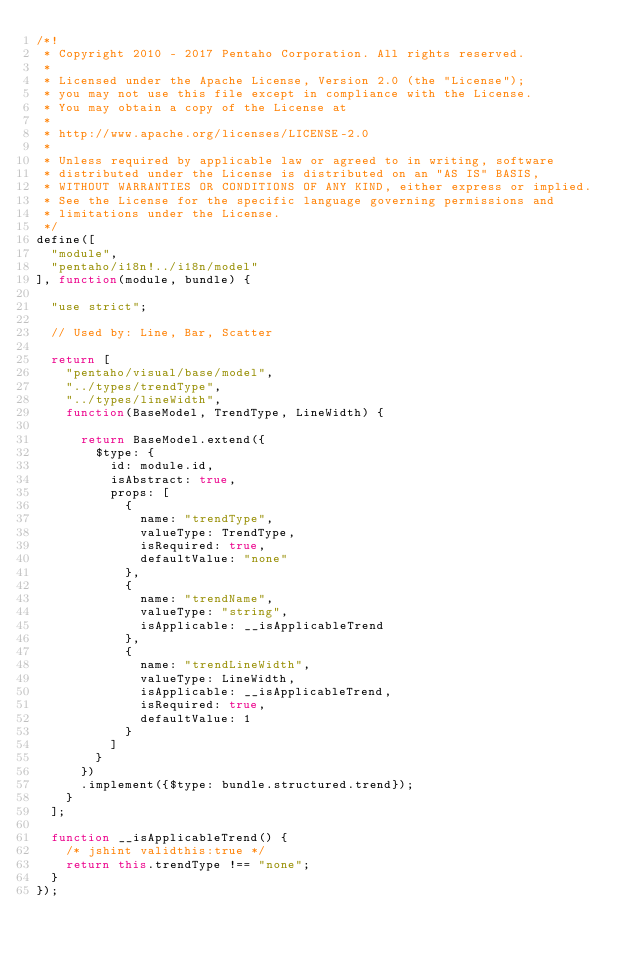Convert code to text. <code><loc_0><loc_0><loc_500><loc_500><_JavaScript_>/*!
 * Copyright 2010 - 2017 Pentaho Corporation. All rights reserved.
 *
 * Licensed under the Apache License, Version 2.0 (the "License");
 * you may not use this file except in compliance with the License.
 * You may obtain a copy of the License at
 *
 * http://www.apache.org/licenses/LICENSE-2.0
 *
 * Unless required by applicable law or agreed to in writing, software
 * distributed under the License is distributed on an "AS IS" BASIS,
 * WITHOUT WARRANTIES OR CONDITIONS OF ANY KIND, either express or implied.
 * See the License for the specific language governing permissions and
 * limitations under the License.
 */
define([
  "module",
  "pentaho/i18n!../i18n/model"
], function(module, bundle) {

  "use strict";

  // Used by: Line, Bar, Scatter

  return [
    "pentaho/visual/base/model",
    "../types/trendType",
    "../types/lineWidth",
    function(BaseModel, TrendType, LineWidth) {

      return BaseModel.extend({
        $type: {
          id: module.id,
          isAbstract: true,
          props: [
            {
              name: "trendType",
              valueType: TrendType,
              isRequired: true,
              defaultValue: "none"
            },
            {
              name: "trendName",
              valueType: "string",
              isApplicable: __isApplicableTrend
            },
            {
              name: "trendLineWidth",
              valueType: LineWidth,
              isApplicable: __isApplicableTrend,
              isRequired: true,
              defaultValue: 1
            }
          ]
        }
      })
      .implement({$type: bundle.structured.trend});
    }
  ];

  function __isApplicableTrend() {
    /* jshint validthis:true */
    return this.trendType !== "none";
  }
});
</code> 